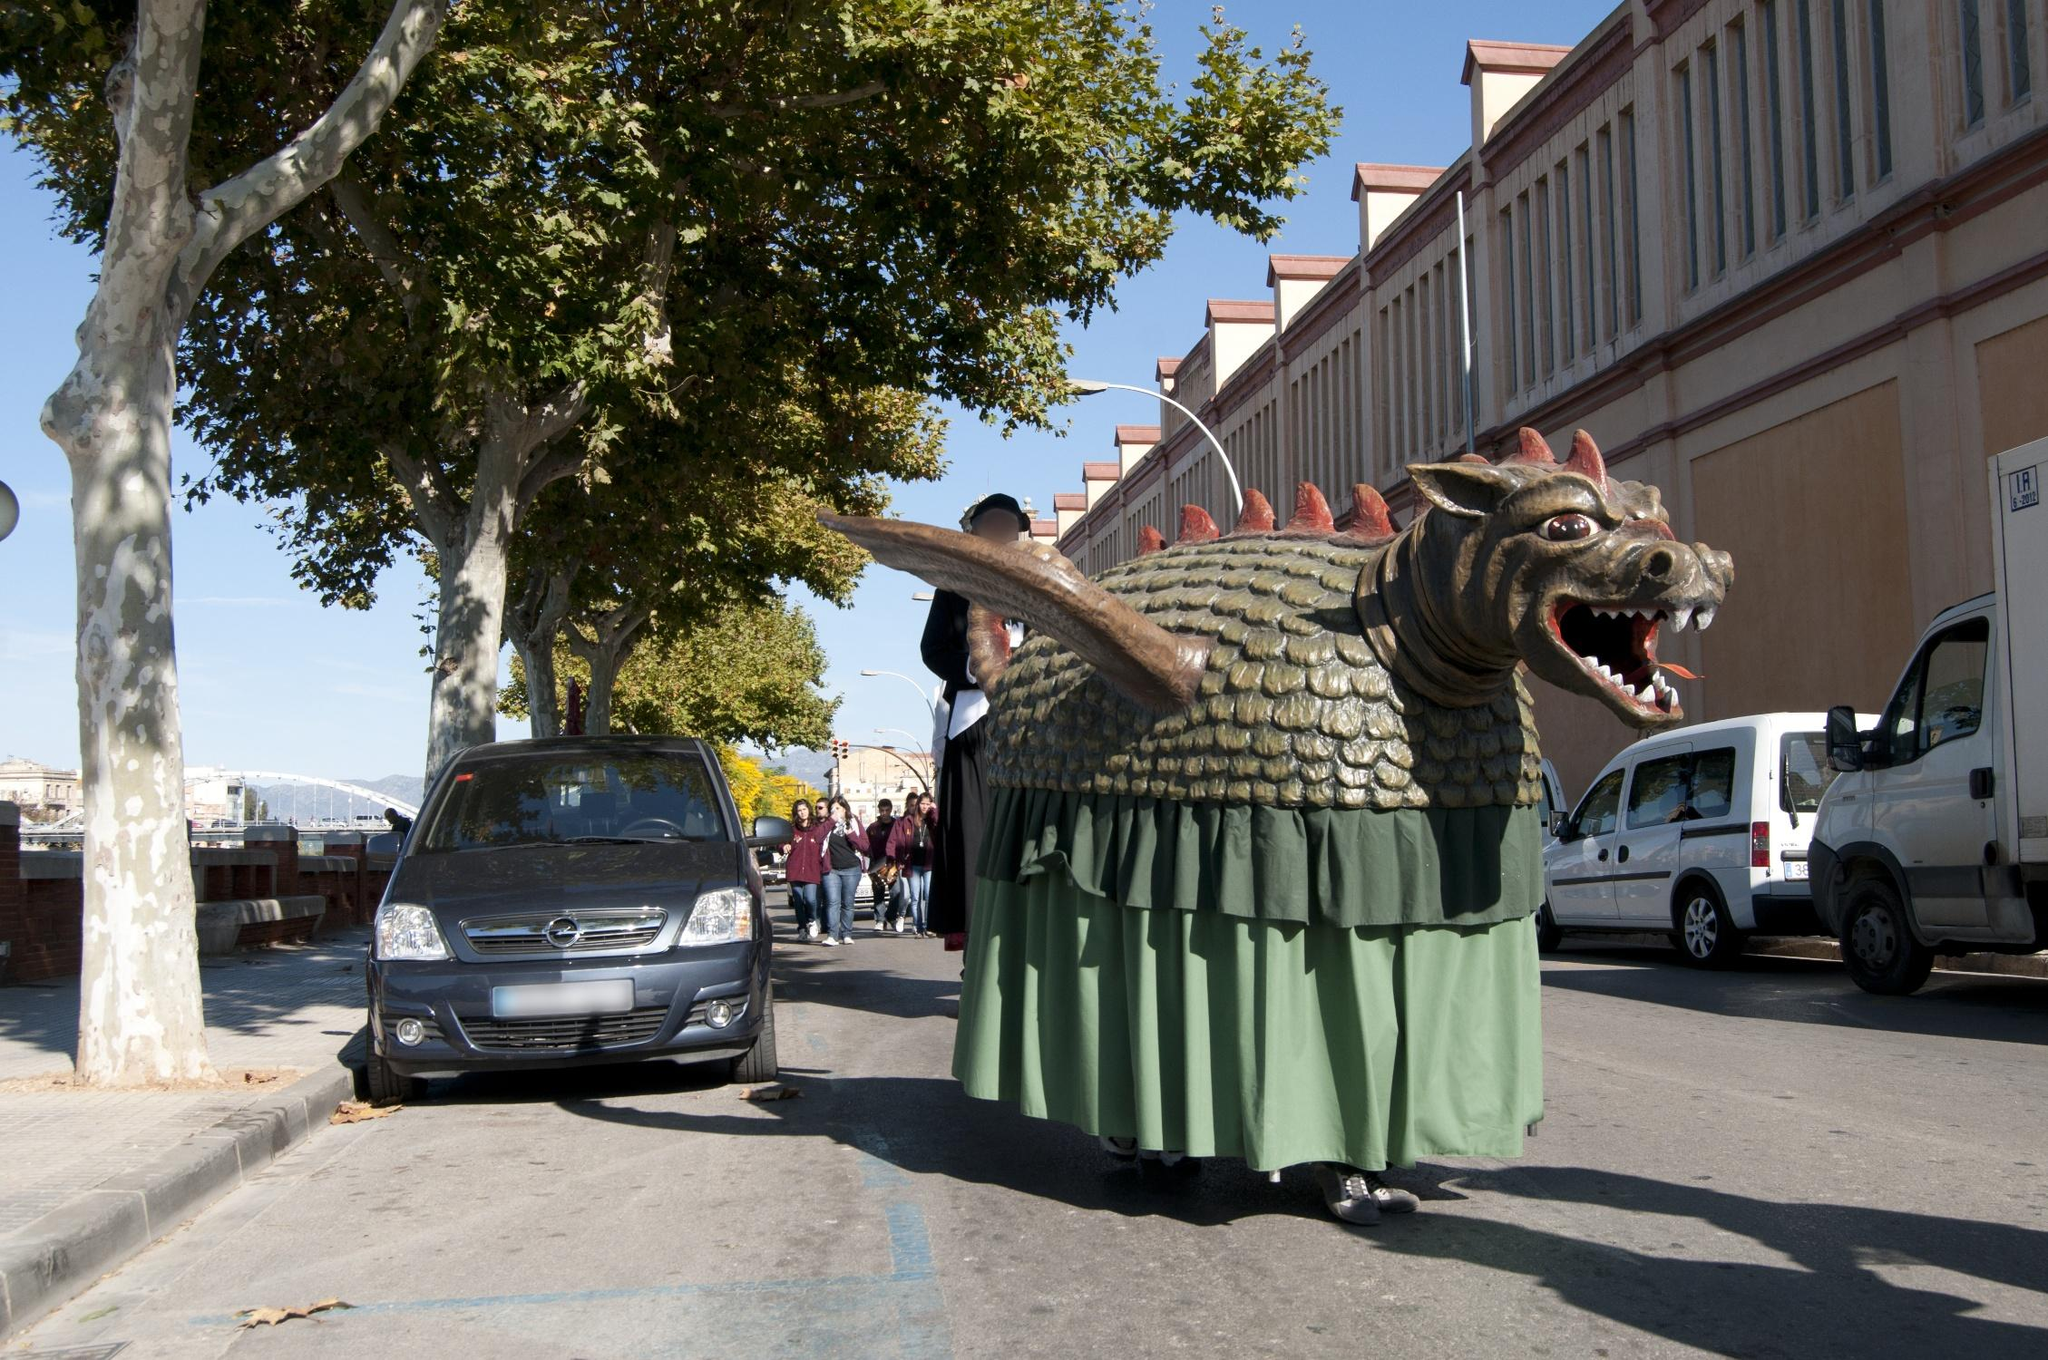What is the significance of the dragon float in the image? The dragon float in the image is likely a central element of a traditional Catalonian festival, such as the Correfoc, where figures dressed as devils and mythical creatures parade and perform in the streets. The dragon, with its fierce appearance and large size, could symbolize protection and strength, and it would be accompanied by fireworks, music, and dancing as part of the celebration. These festivals are deeply rooted in local culture and are celebrated with fervor and enthusiasm, showcasing the region's rich heritage. Tell me more about the events and activities that happen during such festivals. During Catalonian festivals like the Correfoc, the streets come alive with a series of dynamic and thrilling events. One of the highlights is a parade featuring elaborate floats, such as the dragon in the image, alongside performers dressed as devils, who wield firecrackers and pyrotechnic devices, creating a fiery spectacle. The participants run through the streets, often interacting with the crowd, creating a mesmerizing display of light and sound.

In addition to the parade, the festival includes live music performances, traditional dances like the Sardana, and various cultural exhibits that highlight Catalonia's rich history and traditions. Food stalls offering local delicacies such as butifarra (sausages), calçots (a type of onion), and sweet treats like panellets are common, allowing visitors to indulge in regional cuisine.

Communal activities like castells, where teams build human towers, and gegants i capgrossos, featuring giant papier-mâché figures, are also popular. These events foster a sense of community and local pride, bringing people of all ages together to celebrate their cultural heritage.

Overall, these festivals are a blend of ancient traditions and modern entertainment, providing a unique and unforgettable experience. 